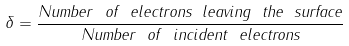Convert formula to latex. <formula><loc_0><loc_0><loc_500><loc_500>\delta = \frac { N u m b e r \ o f \ e l e c t r o n s \ l e a v i n g \ t h e \ s u r f a c e } { N u m b e r \ o f \ i n c i d e n t \ e l e c t r o n s }</formula> 